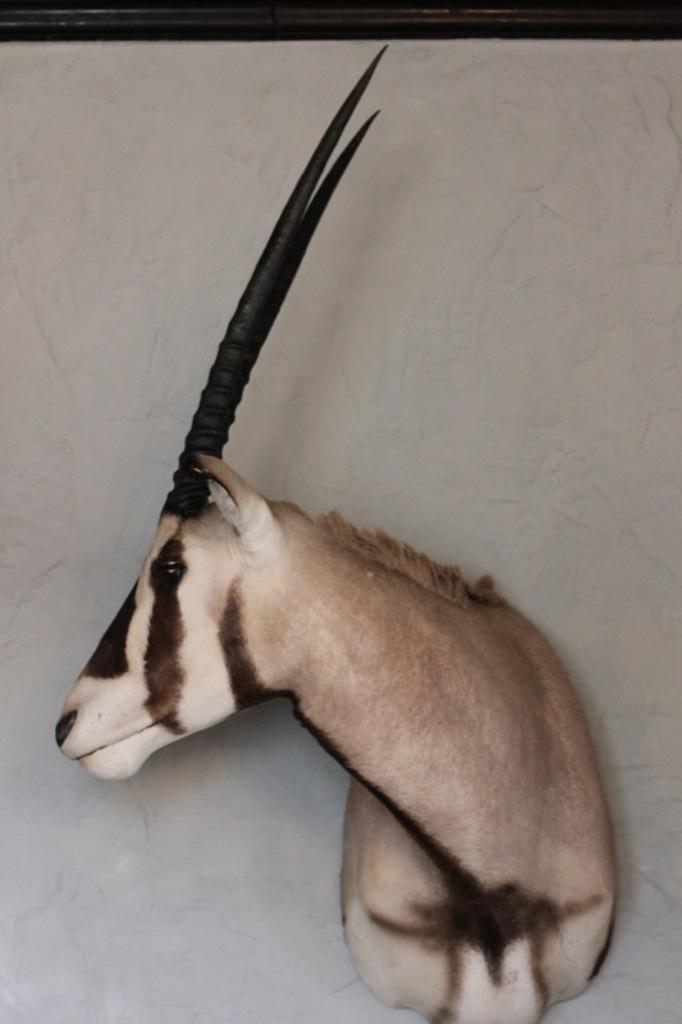What is the main subject of the image? There is an animal statue in the image. What colors are used for the statue? The statue is in brown and black colors. What is the color of the surface on which the statue is placed? The statue is on a white surface. How much profit does the statue generate in the image? The image does not depict any profit or financial transactions, as it is a static representation of an animal statue. 